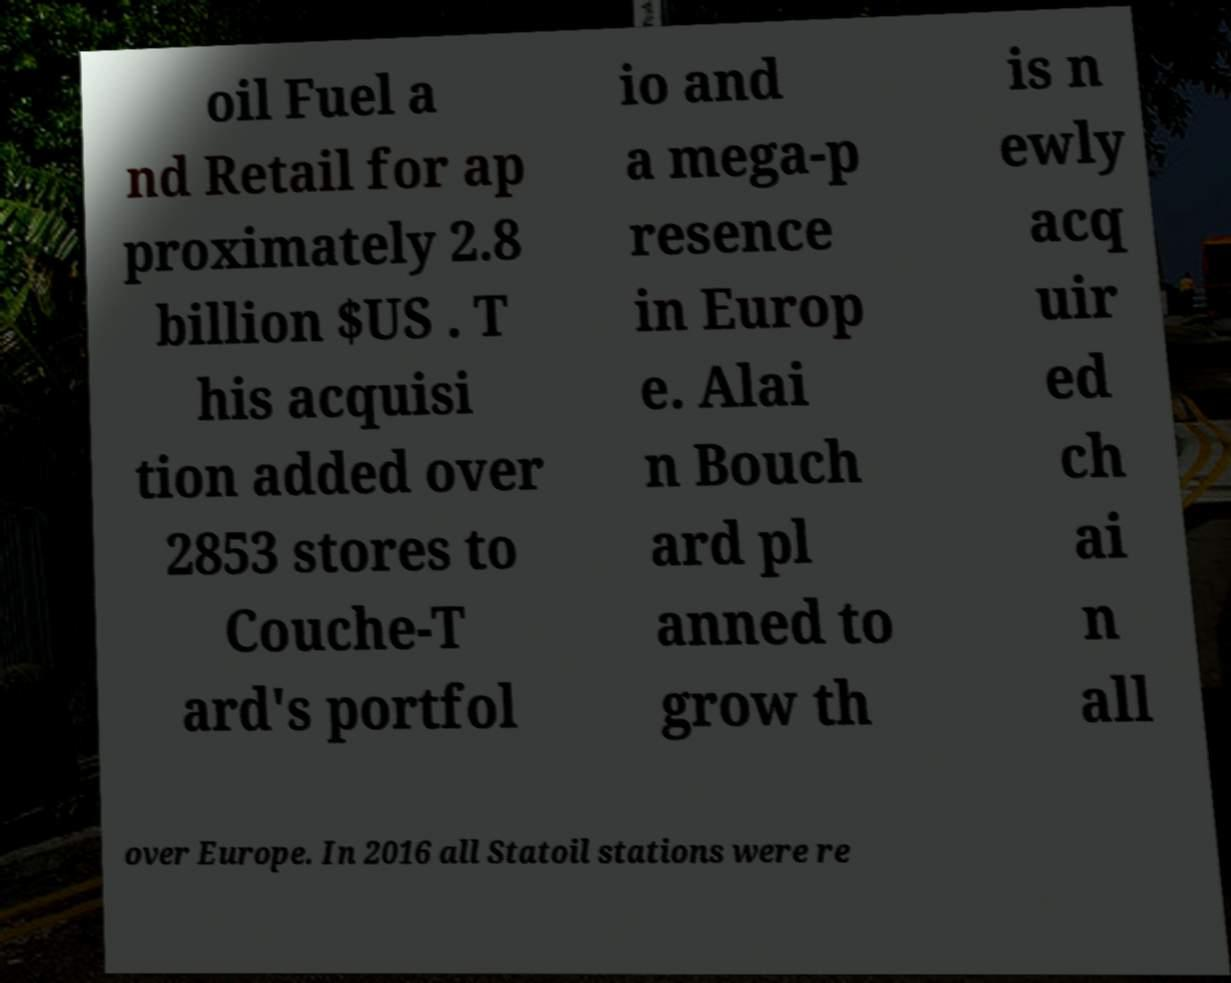Can you accurately transcribe the text from the provided image for me? oil Fuel a nd Retail for ap proximately 2.8 billion $US . T his acquisi tion added over 2853 stores to Couche-T ard's portfol io and a mega-p resence in Europ e. Alai n Bouch ard pl anned to grow th is n ewly acq uir ed ch ai n all over Europe. In 2016 all Statoil stations were re 